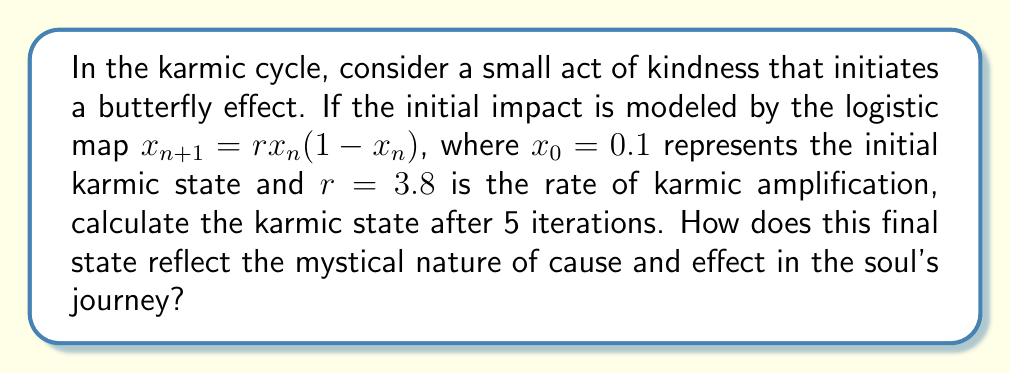Help me with this question. To model the butterfly effect of a small action on the karmic cycle using chaos theory, we'll use the logistic map equation and iterate it 5 times:

1. Initial state: $x_0 = 0.1$
2. Rate of karmic amplification: $r = 3.8$
3. Logistic map: $x_{n+1} = rx_n(1-x_n)$

Let's calculate each iteration:

Iteration 1: $x_1 = 3.8 \cdot 0.1 \cdot (1-0.1) = 0.342$

Iteration 2: $x_2 = 3.8 \cdot 0.342 \cdot (1-0.342) = 0.855884$

Iteration 3: $x_3 = 3.8 \cdot 0.855884 \cdot (1-0.855884) = 0.468954$

Iteration 4: $x_4 = 3.8 \cdot 0.468954 \cdot (1-0.468954) = 0.948330$

Iteration 5: $x_5 = 3.8 \cdot 0.948330 \cdot (1-0.948330) = 0.186128$

The final karmic state after 5 iterations is approximately 0.186128. This result demonstrates the unpredictable nature of karma and how small actions can lead to significant and unexpected changes in one's spiritual journey. The chaotic behavior of the system reflects the mystical interconnectedness of all actions and their consequences in the grand tapestry of existence.
Answer: 0.186128 